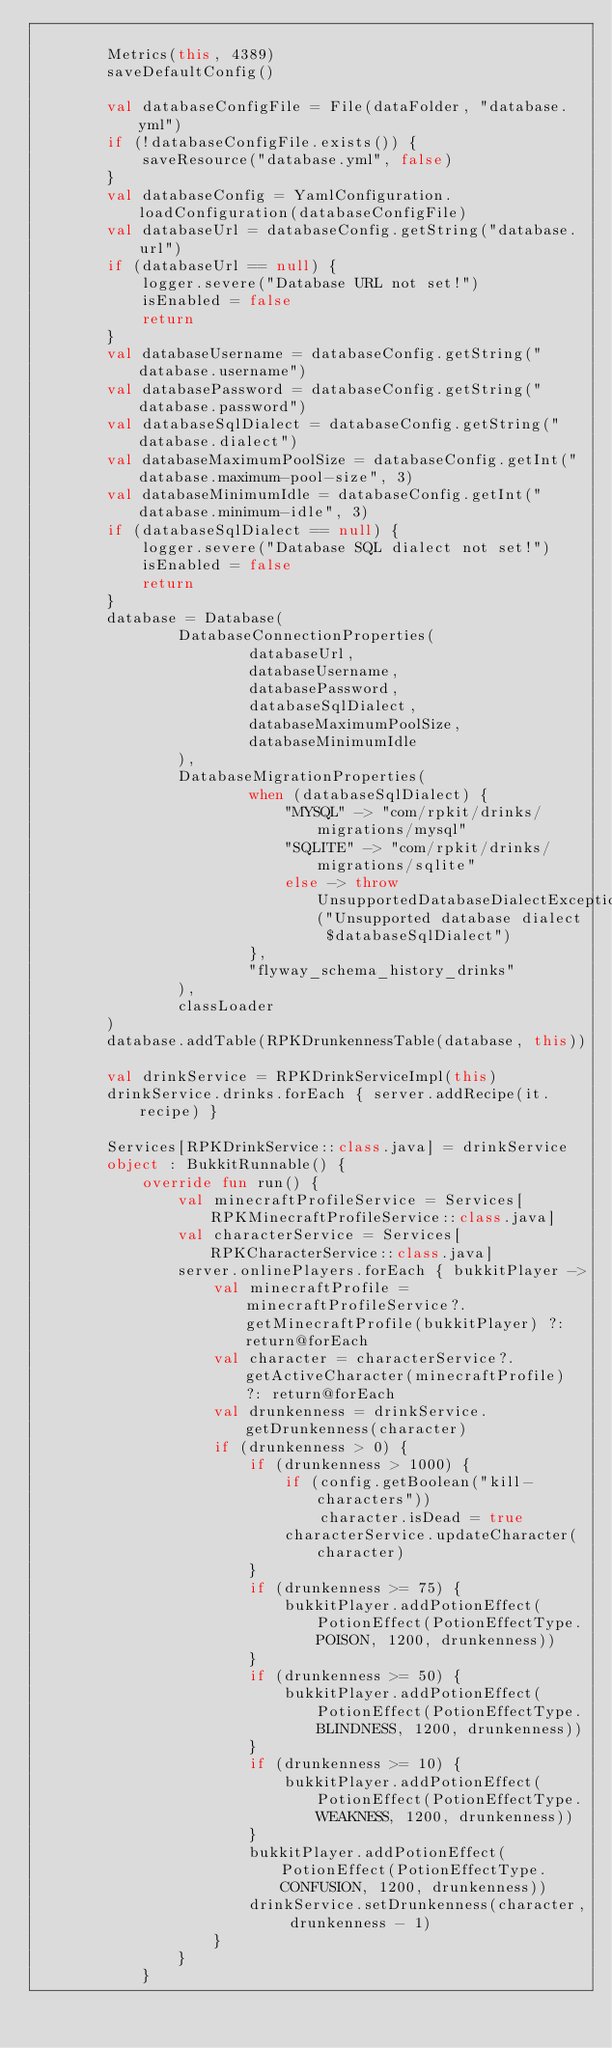Convert code to text. <code><loc_0><loc_0><loc_500><loc_500><_Kotlin_>
        Metrics(this, 4389)
        saveDefaultConfig()

        val databaseConfigFile = File(dataFolder, "database.yml")
        if (!databaseConfigFile.exists()) {
            saveResource("database.yml", false)
        }
        val databaseConfig = YamlConfiguration.loadConfiguration(databaseConfigFile)
        val databaseUrl = databaseConfig.getString("database.url")
        if (databaseUrl == null) {
            logger.severe("Database URL not set!")
            isEnabled = false
            return
        }
        val databaseUsername = databaseConfig.getString("database.username")
        val databasePassword = databaseConfig.getString("database.password")
        val databaseSqlDialect = databaseConfig.getString("database.dialect")
        val databaseMaximumPoolSize = databaseConfig.getInt("database.maximum-pool-size", 3)
        val databaseMinimumIdle = databaseConfig.getInt("database.minimum-idle", 3)
        if (databaseSqlDialect == null) {
            logger.severe("Database SQL dialect not set!")
            isEnabled = false
            return
        }
        database = Database(
                DatabaseConnectionProperties(
                        databaseUrl,
                        databaseUsername,
                        databasePassword,
                        databaseSqlDialect,
                        databaseMaximumPoolSize,
                        databaseMinimumIdle
                ),
                DatabaseMigrationProperties(
                        when (databaseSqlDialect) {
                            "MYSQL" -> "com/rpkit/drinks/migrations/mysql"
                            "SQLITE" -> "com/rpkit/drinks/migrations/sqlite"
                            else -> throw UnsupportedDatabaseDialectException("Unsupported database dialect $databaseSqlDialect")
                        },
                        "flyway_schema_history_drinks"
                ),
                classLoader
        )
        database.addTable(RPKDrunkennessTable(database, this))

        val drinkService = RPKDrinkServiceImpl(this)
        drinkService.drinks.forEach { server.addRecipe(it.recipe) }

        Services[RPKDrinkService::class.java] = drinkService
        object : BukkitRunnable() {
            override fun run() {
                val minecraftProfileService = Services[RPKMinecraftProfileService::class.java]
                val characterService = Services[RPKCharacterService::class.java]
                server.onlinePlayers.forEach { bukkitPlayer ->
                    val minecraftProfile = minecraftProfileService?.getMinecraftProfile(bukkitPlayer) ?: return@forEach
                    val character = characterService?.getActiveCharacter(minecraftProfile) ?: return@forEach
                    val drunkenness = drinkService.getDrunkenness(character)
                    if (drunkenness > 0) {
                        if (drunkenness > 1000) {
                            if (config.getBoolean("kill-characters"))
                                character.isDead = true
                            characterService.updateCharacter(character)
                        }
                        if (drunkenness >= 75) {
                            bukkitPlayer.addPotionEffect(PotionEffect(PotionEffectType.POISON, 1200, drunkenness))
                        }
                        if (drunkenness >= 50) {
                            bukkitPlayer.addPotionEffect(PotionEffect(PotionEffectType.BLINDNESS, 1200, drunkenness))
                        }
                        if (drunkenness >= 10) {
                            bukkitPlayer.addPotionEffect(PotionEffect(PotionEffectType.WEAKNESS, 1200, drunkenness))
                        }
                        bukkitPlayer.addPotionEffect(PotionEffect(PotionEffectType.CONFUSION, 1200, drunkenness))
                        drinkService.setDrunkenness(character, drunkenness - 1)
                    }
                }
            }</code> 